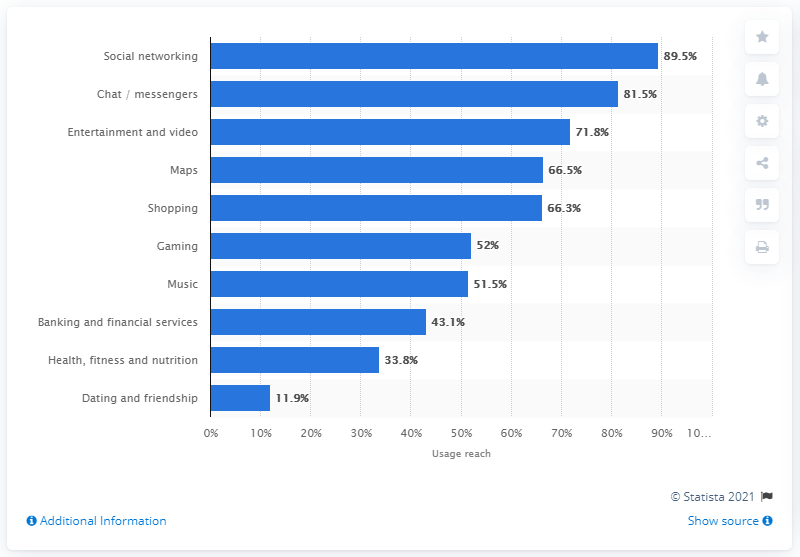Point out several critical features in this image. According to a report, 11.9% of internet users in the U.S. stated that they have used online dating apps. 